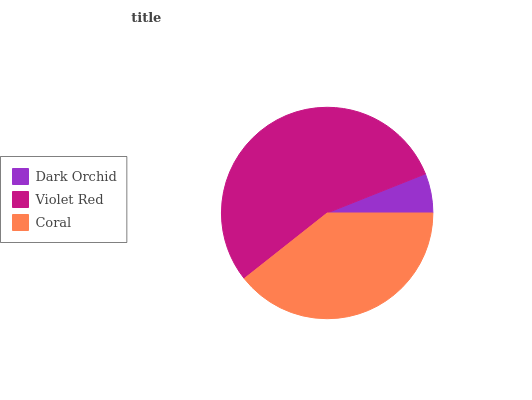Is Dark Orchid the minimum?
Answer yes or no. Yes. Is Violet Red the maximum?
Answer yes or no. Yes. Is Coral the minimum?
Answer yes or no. No. Is Coral the maximum?
Answer yes or no. No. Is Violet Red greater than Coral?
Answer yes or no. Yes. Is Coral less than Violet Red?
Answer yes or no. Yes. Is Coral greater than Violet Red?
Answer yes or no. No. Is Violet Red less than Coral?
Answer yes or no. No. Is Coral the high median?
Answer yes or no. Yes. Is Coral the low median?
Answer yes or no. Yes. Is Violet Red the high median?
Answer yes or no. No. Is Violet Red the low median?
Answer yes or no. No. 